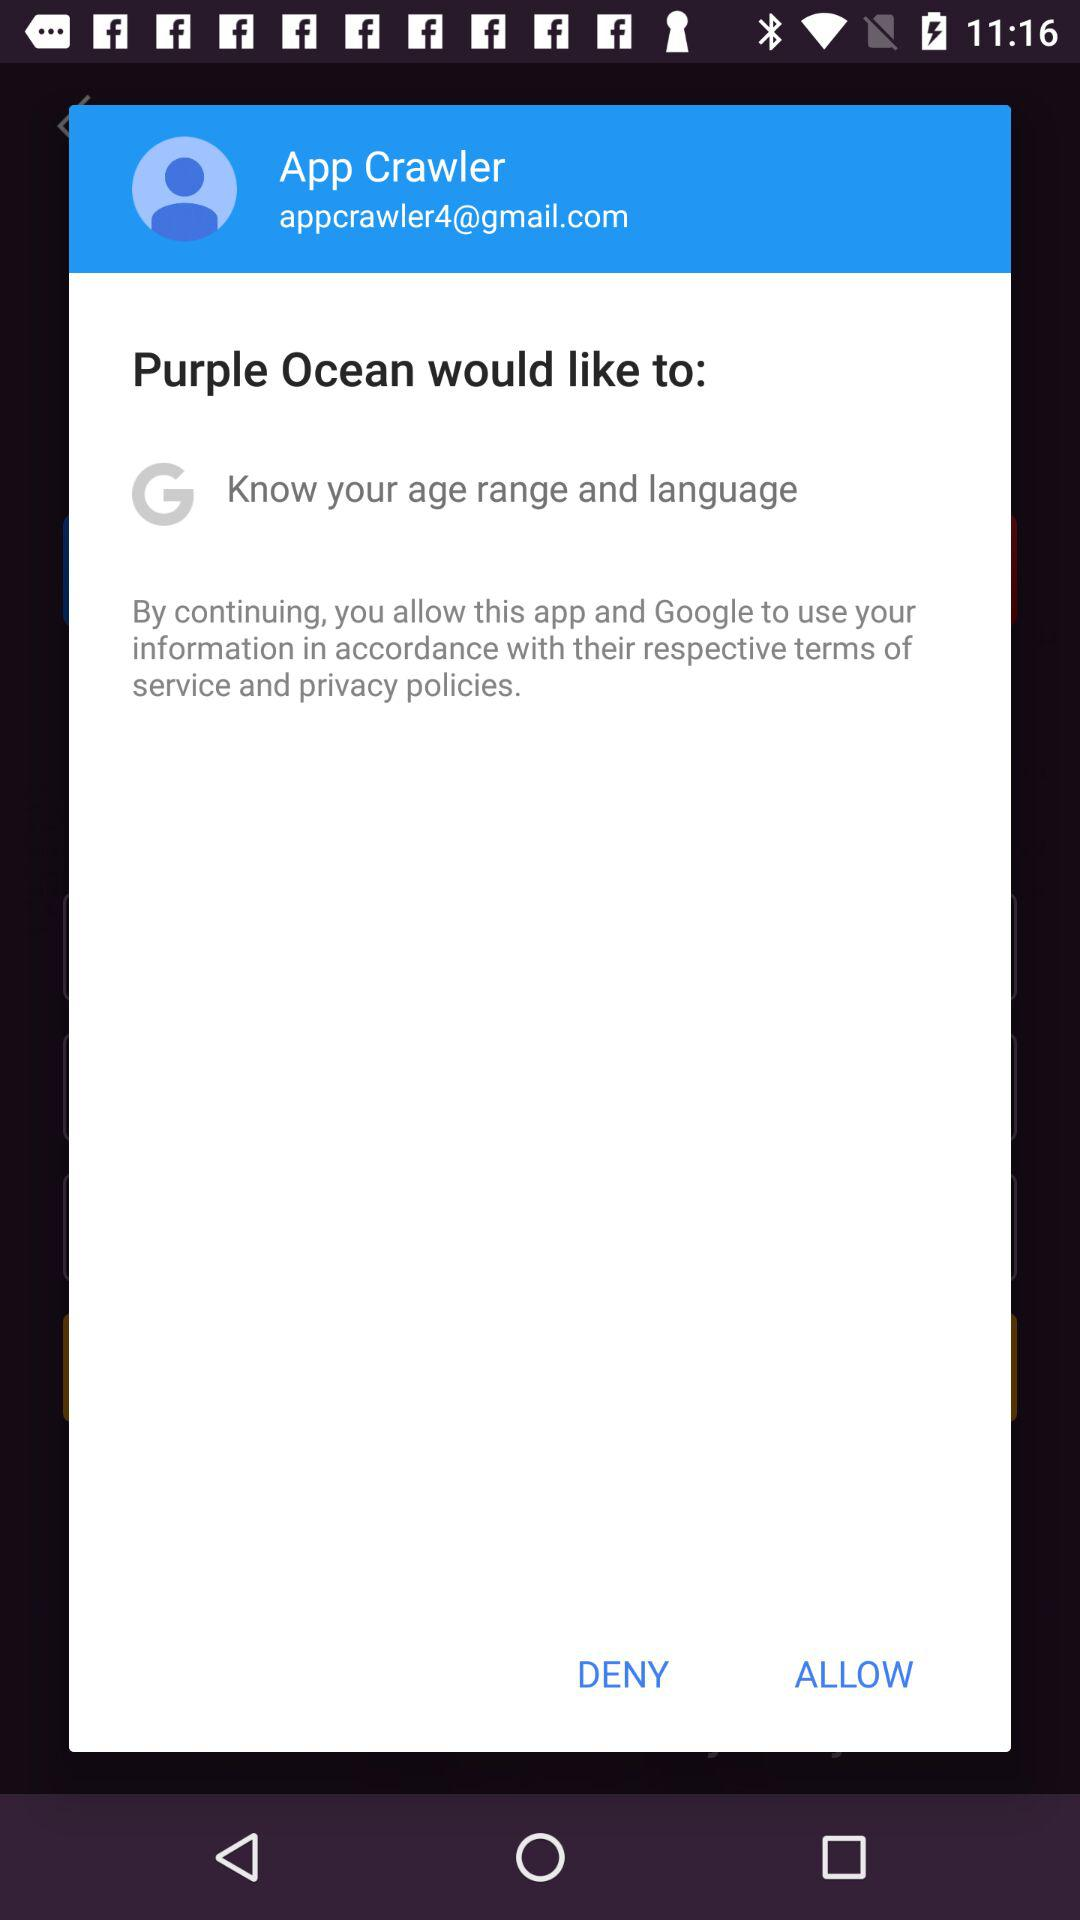What is the email address? The email address is appcrawler4@gmail.com. 